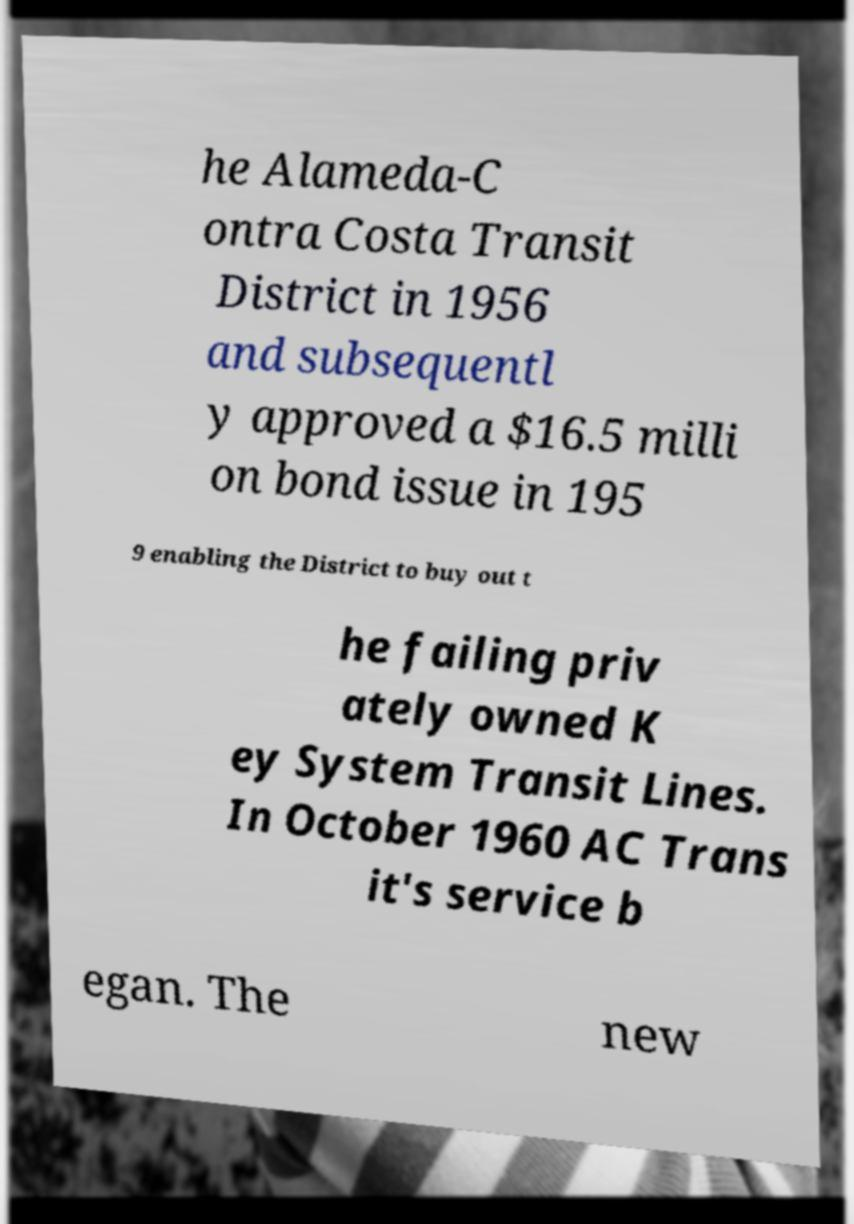I need the written content from this picture converted into text. Can you do that? he Alameda-C ontra Costa Transit District in 1956 and subsequentl y approved a $16.5 milli on bond issue in 195 9 enabling the District to buy out t he failing priv ately owned K ey System Transit Lines. In October 1960 AC Trans it's service b egan. The new 